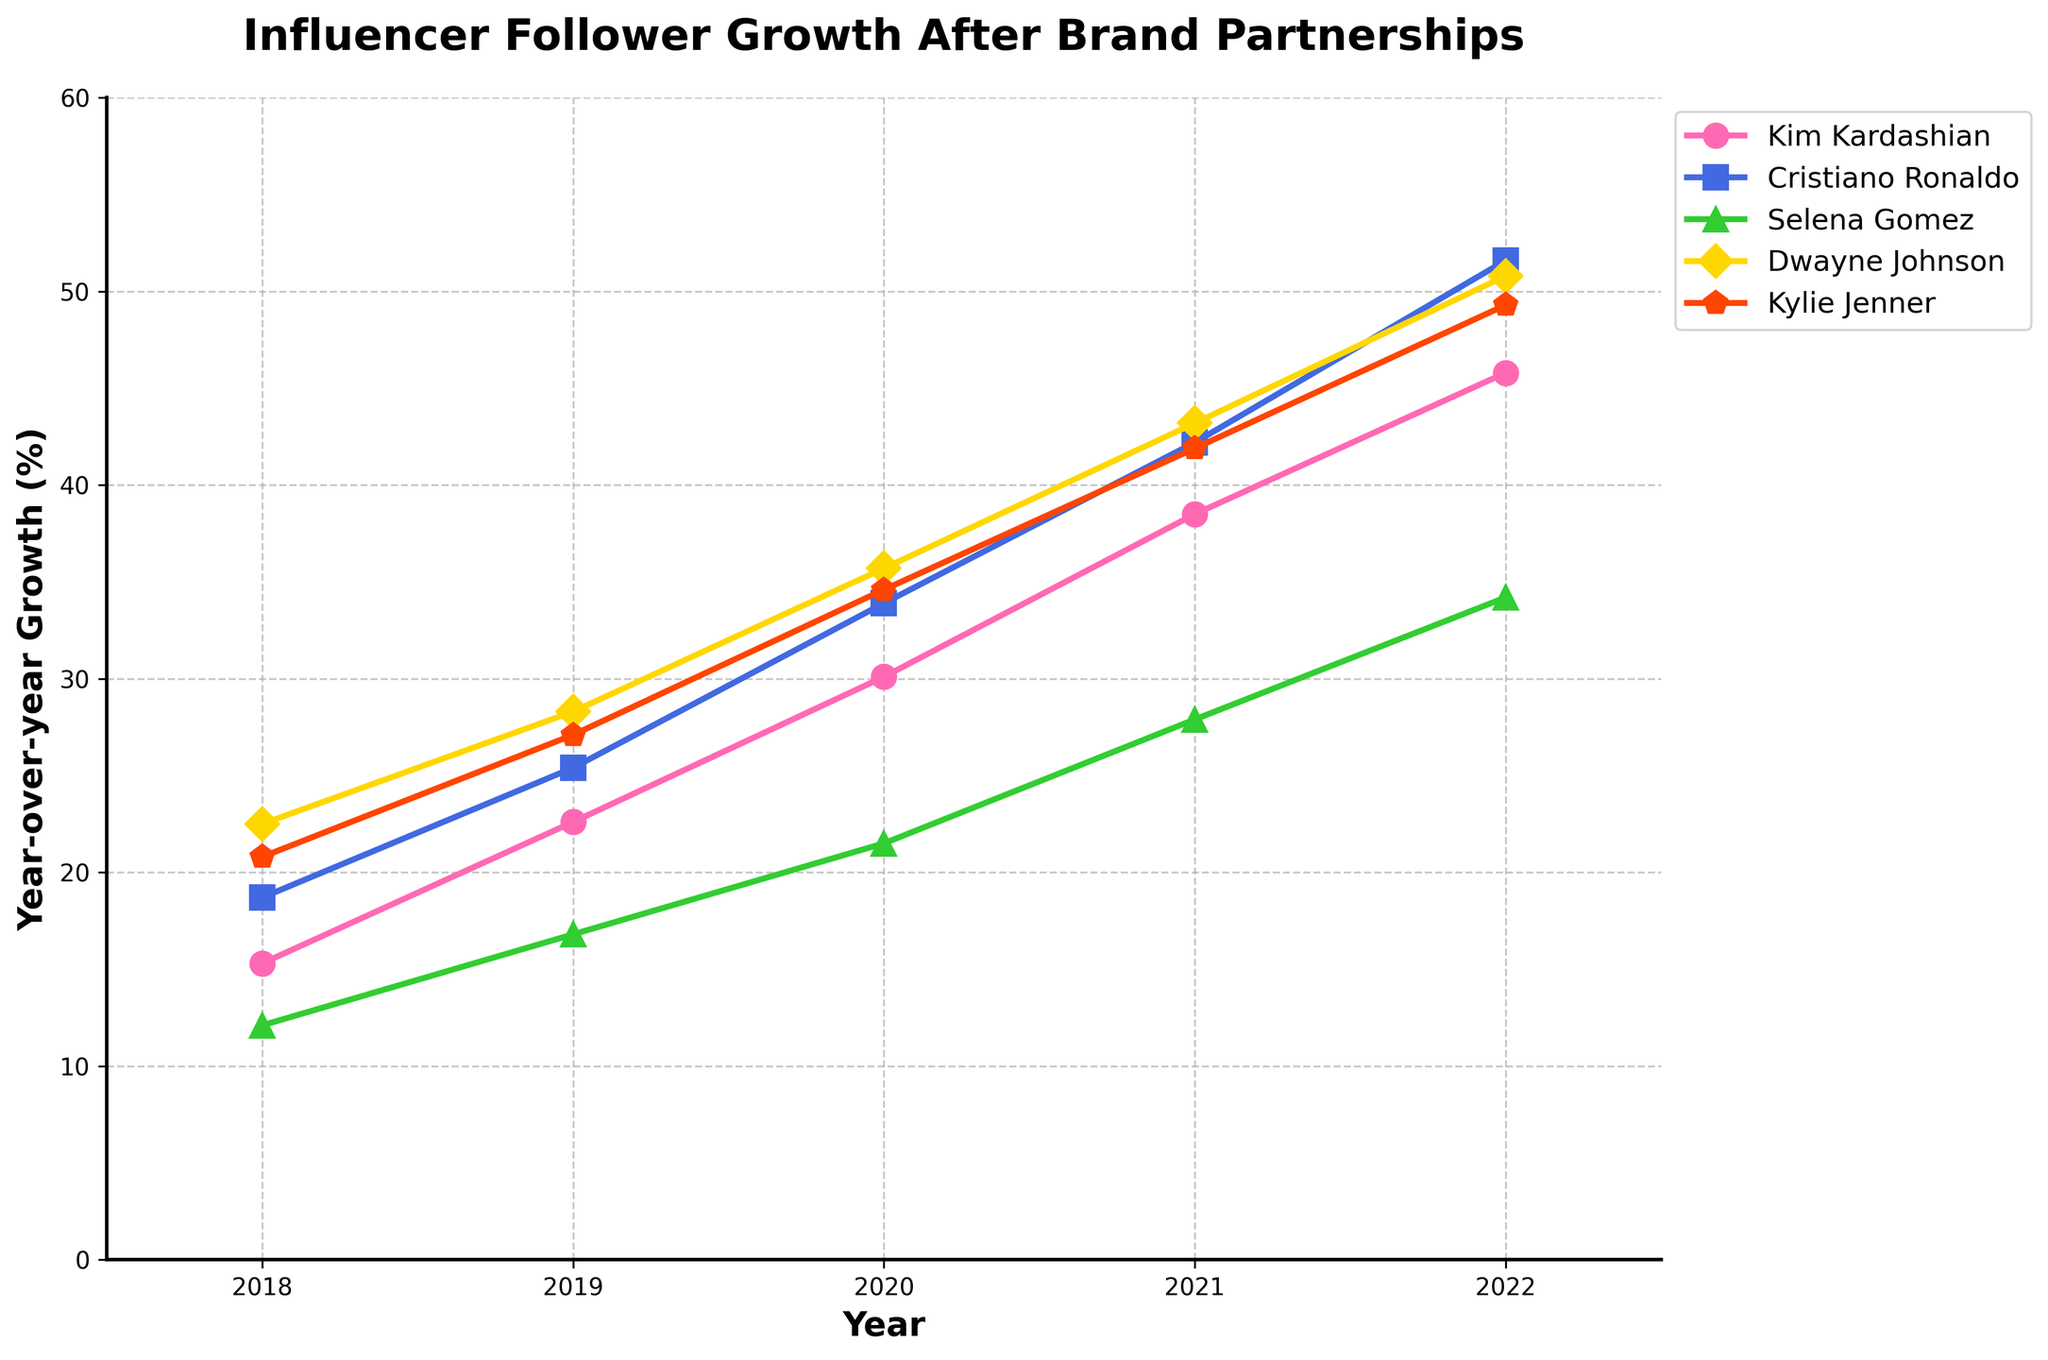What's the year-over-year growth of Cristiano Ronaldo in 2020? Find the data point for Cristiano Ronaldo in 2020 from the chart. It shows he had a growth of 33.9%.
Answer: 33.9% Which influencer had the highest year-over-year growth in 2021? Compare the growth rates of all influencers in 2021. Dwayne Johnson and Cristiano Ronaldo both had the highest growth rates at 42.2% and 43.2% respectively, but Dwayne Johnson is slightly higher.
Answer: Dwayne Johnson Which two influencers had the closest growth rates in 2022? Compare the 2022 growth rates for all influencers. Kim Kardashian and Selena Gomez had the closest values at 45.8% and 49.3%, respectively.
Answer: Kim Kardashian and Selena Gomez What was the average year-over-year growth of all influencers in 2019? Sum the 2019 growth rates for all influencers (22.6 + 25.4 + 16.8 + 28.3 + 27.1) and divide by the number of influencers (5).
Answer: 24.04% How much higher was Kylie Jenner's growth compared to Selena Gomez's in 2020? Find the difference between their 2020 growth rates: 34.6% (Kylie) - 21.5% (Selena).
Answer: 13.1% During which year did Kim Kardashian experience the highest growth rate? Identify the highest year-over-year growth rate for Kim Kardashian across all the years from the chart. The highest value is in 2022 at 45.8%.
Answer: 2022 Which influencer showed a consistent increase in their growth every year? Analyze the growth of each influencer year by year. Each influencer consistently increased their growth every year.
Answer: All influencers What is the median year-over-year growth of Selena Gomez from 2018 to 2022? Arrange the growth rates of Selena Gomez from 2018 to 2022 (12.1, 16.8, 21.5, 27.9, 34.2) in ascending order, the median is 21.5%.
Answer: 21.5% Can we say that Dwayne Johnson's growth rate in 2020 was closer to Cristiano Ronaldo's or Kim Kardashian's? Compare Dwayne Johnson's growth rate in 2020 (35.7%) against Cristiano Ronaldo's (33.9%) and Kim Kardashian's (30.1%).
Answer: Cristiano Ronaldo 